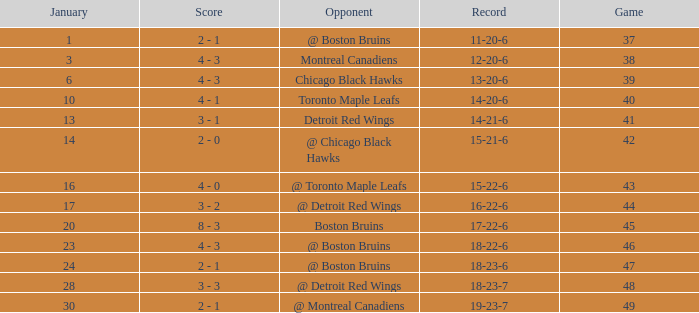What day in January was the game greater than 49 and had @ Montreal Canadiens as opponents? None. 